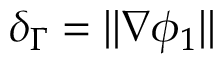<formula> <loc_0><loc_0><loc_500><loc_500>\delta _ { \Gamma } = | | \nabla \phi _ { 1 } | |</formula> 